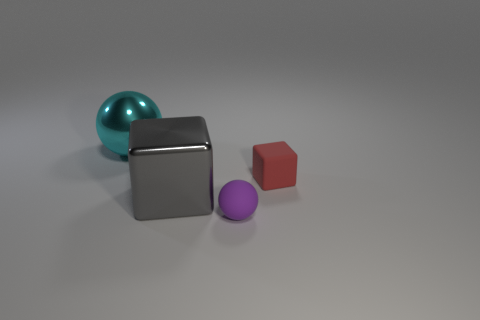Add 4 small brown shiny cylinders. How many small brown shiny cylinders exist? 4 Add 3 large blocks. How many objects exist? 7 Subtract all purple spheres. How many spheres are left? 1 Subtract 0 yellow cylinders. How many objects are left? 4 Subtract 2 spheres. How many spheres are left? 0 Subtract all purple balls. Subtract all green blocks. How many balls are left? 1 Subtract all blue balls. How many gray cubes are left? 1 Subtract all gray blocks. Subtract all red rubber objects. How many objects are left? 2 Add 2 small rubber things. How many small rubber things are left? 4 